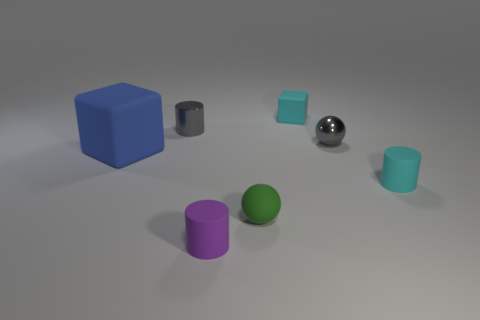Are the purple cylinder and the cyan cylinder made of the same material? While both the purple and cyan cylinders appear to have a similar matte surface finish, suggesting they could be made of the same material, we cannot determine the material composition from a visual inspection alone. Materials can have different intrinsic properties but present similar visual aspects, especially in a rendered image. 